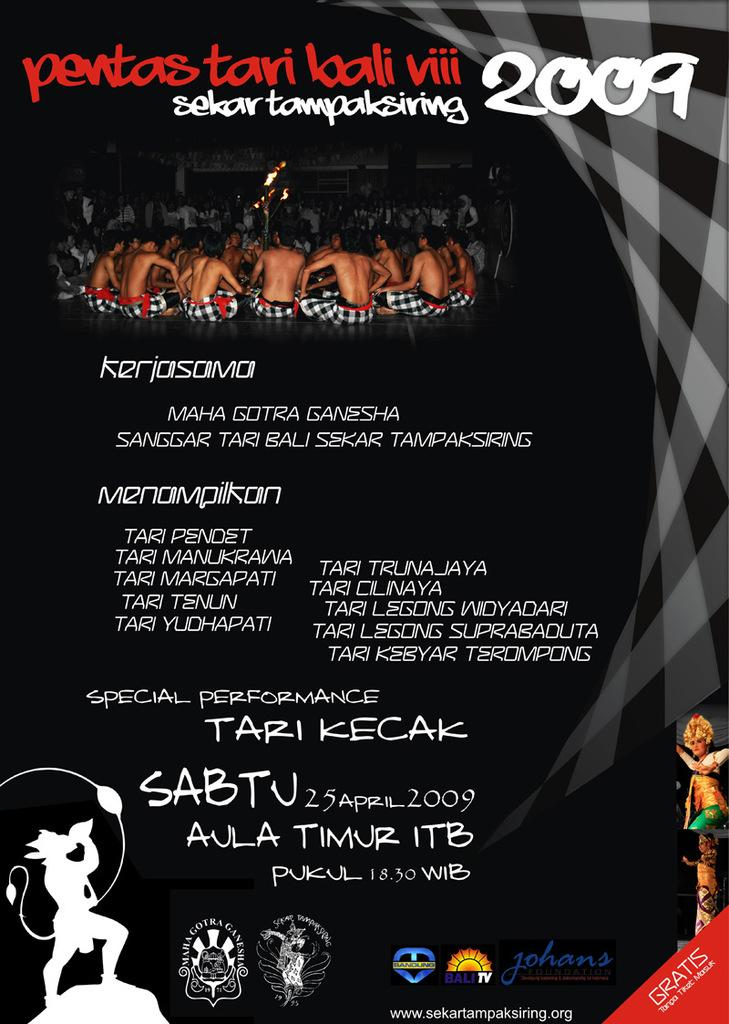<image>
Give a short and clear explanation of the subsequent image. A poster for a special performance by Tari Kecak. 